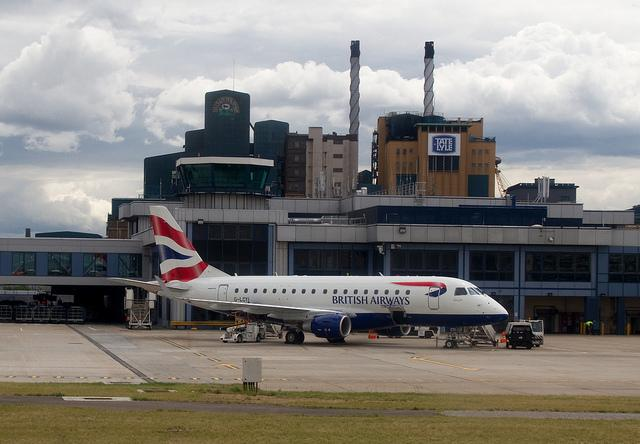What is placed in the underneath of a plane storage?

Choices:
A) passangers
B) luggage
C) flight attendant
D) pilot luggage 